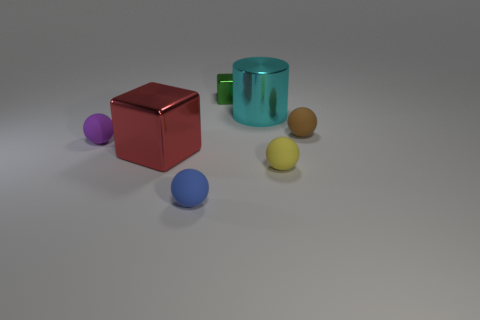Add 2 large shiny cylinders. How many objects exist? 9 Subtract all spheres. How many objects are left? 3 Add 1 small brown things. How many small brown things are left? 2 Add 3 shiny cylinders. How many shiny cylinders exist? 4 Subtract 0 brown blocks. How many objects are left? 7 Subtract all small shiny objects. Subtract all small brown things. How many objects are left? 5 